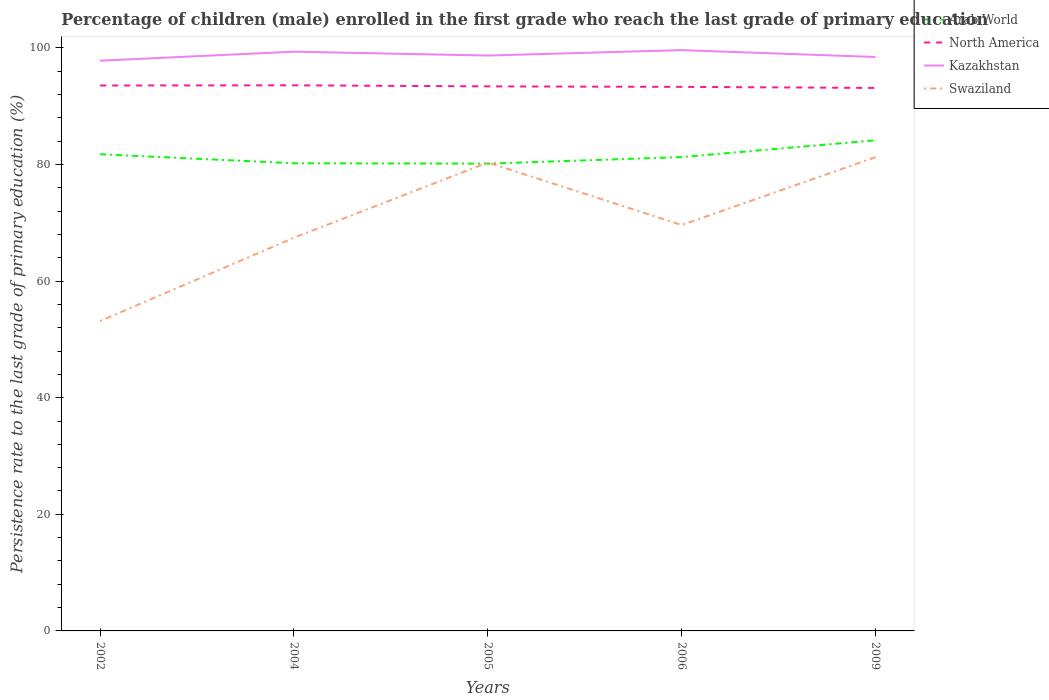Across all years, what is the maximum persistence rate of children in Swaziland?
Offer a terse response. 53.15. In which year was the persistence rate of children in Kazakhstan maximum?
Your answer should be compact. 2002. What is the total persistence rate of children in Swaziland in the graph?
Your response must be concise. -27.18. What is the difference between the highest and the second highest persistence rate of children in Arab World?
Give a very brief answer. 4.01. What is the difference between the highest and the lowest persistence rate of children in Swaziland?
Make the answer very short. 2. How many years are there in the graph?
Provide a succinct answer. 5. Does the graph contain grids?
Offer a very short reply. No. How are the legend labels stacked?
Offer a terse response. Vertical. What is the title of the graph?
Keep it short and to the point. Percentage of children (male) enrolled in the first grade who reach the last grade of primary education. Does "Malaysia" appear as one of the legend labels in the graph?
Give a very brief answer. No. What is the label or title of the X-axis?
Provide a succinct answer. Years. What is the label or title of the Y-axis?
Make the answer very short. Persistence rate to the last grade of primary education (%). What is the Persistence rate to the last grade of primary education (%) in Arab World in 2002?
Provide a succinct answer. 81.75. What is the Persistence rate to the last grade of primary education (%) in North America in 2002?
Ensure brevity in your answer.  93.54. What is the Persistence rate to the last grade of primary education (%) of Kazakhstan in 2002?
Offer a terse response. 97.79. What is the Persistence rate to the last grade of primary education (%) in Swaziland in 2002?
Ensure brevity in your answer.  53.15. What is the Persistence rate to the last grade of primary education (%) in Arab World in 2004?
Keep it short and to the point. 80.2. What is the Persistence rate to the last grade of primary education (%) in North America in 2004?
Ensure brevity in your answer.  93.57. What is the Persistence rate to the last grade of primary education (%) of Kazakhstan in 2004?
Your answer should be compact. 99.34. What is the Persistence rate to the last grade of primary education (%) in Swaziland in 2004?
Offer a terse response. 67.44. What is the Persistence rate to the last grade of primary education (%) in Arab World in 2005?
Provide a succinct answer. 80.13. What is the Persistence rate to the last grade of primary education (%) of North America in 2005?
Provide a succinct answer. 93.38. What is the Persistence rate to the last grade of primary education (%) in Kazakhstan in 2005?
Provide a short and direct response. 98.67. What is the Persistence rate to the last grade of primary education (%) in Swaziland in 2005?
Make the answer very short. 80.33. What is the Persistence rate to the last grade of primary education (%) in Arab World in 2006?
Ensure brevity in your answer.  81.26. What is the Persistence rate to the last grade of primary education (%) in North America in 2006?
Your answer should be very brief. 93.3. What is the Persistence rate to the last grade of primary education (%) in Kazakhstan in 2006?
Ensure brevity in your answer.  99.6. What is the Persistence rate to the last grade of primary education (%) in Swaziland in 2006?
Provide a short and direct response. 69.61. What is the Persistence rate to the last grade of primary education (%) in Arab World in 2009?
Your response must be concise. 84.14. What is the Persistence rate to the last grade of primary education (%) in North America in 2009?
Your response must be concise. 93.12. What is the Persistence rate to the last grade of primary education (%) of Kazakhstan in 2009?
Offer a very short reply. 98.42. What is the Persistence rate to the last grade of primary education (%) in Swaziland in 2009?
Make the answer very short. 81.24. Across all years, what is the maximum Persistence rate to the last grade of primary education (%) of Arab World?
Offer a very short reply. 84.14. Across all years, what is the maximum Persistence rate to the last grade of primary education (%) in North America?
Provide a succinct answer. 93.57. Across all years, what is the maximum Persistence rate to the last grade of primary education (%) of Kazakhstan?
Your response must be concise. 99.6. Across all years, what is the maximum Persistence rate to the last grade of primary education (%) in Swaziland?
Make the answer very short. 81.24. Across all years, what is the minimum Persistence rate to the last grade of primary education (%) of Arab World?
Give a very brief answer. 80.13. Across all years, what is the minimum Persistence rate to the last grade of primary education (%) of North America?
Make the answer very short. 93.12. Across all years, what is the minimum Persistence rate to the last grade of primary education (%) in Kazakhstan?
Offer a very short reply. 97.79. Across all years, what is the minimum Persistence rate to the last grade of primary education (%) of Swaziland?
Provide a succinct answer. 53.15. What is the total Persistence rate to the last grade of primary education (%) of Arab World in the graph?
Offer a very short reply. 407.49. What is the total Persistence rate to the last grade of primary education (%) in North America in the graph?
Offer a very short reply. 466.91. What is the total Persistence rate to the last grade of primary education (%) of Kazakhstan in the graph?
Provide a short and direct response. 493.83. What is the total Persistence rate to the last grade of primary education (%) of Swaziland in the graph?
Provide a short and direct response. 351.76. What is the difference between the Persistence rate to the last grade of primary education (%) in Arab World in 2002 and that in 2004?
Give a very brief answer. 1.55. What is the difference between the Persistence rate to the last grade of primary education (%) in North America in 2002 and that in 2004?
Provide a succinct answer. -0.03. What is the difference between the Persistence rate to the last grade of primary education (%) of Kazakhstan in 2002 and that in 2004?
Provide a succinct answer. -1.55. What is the difference between the Persistence rate to the last grade of primary education (%) of Swaziland in 2002 and that in 2004?
Provide a succinct answer. -14.29. What is the difference between the Persistence rate to the last grade of primary education (%) in Arab World in 2002 and that in 2005?
Give a very brief answer. 1.61. What is the difference between the Persistence rate to the last grade of primary education (%) in North America in 2002 and that in 2005?
Your answer should be very brief. 0.15. What is the difference between the Persistence rate to the last grade of primary education (%) in Kazakhstan in 2002 and that in 2005?
Give a very brief answer. -0.88. What is the difference between the Persistence rate to the last grade of primary education (%) in Swaziland in 2002 and that in 2005?
Provide a short and direct response. -27.18. What is the difference between the Persistence rate to the last grade of primary education (%) of Arab World in 2002 and that in 2006?
Provide a short and direct response. 0.48. What is the difference between the Persistence rate to the last grade of primary education (%) in North America in 2002 and that in 2006?
Offer a very short reply. 0.24. What is the difference between the Persistence rate to the last grade of primary education (%) of Kazakhstan in 2002 and that in 2006?
Ensure brevity in your answer.  -1.81. What is the difference between the Persistence rate to the last grade of primary education (%) in Swaziland in 2002 and that in 2006?
Keep it short and to the point. -16.46. What is the difference between the Persistence rate to the last grade of primary education (%) in Arab World in 2002 and that in 2009?
Your answer should be very brief. -2.4. What is the difference between the Persistence rate to the last grade of primary education (%) in North America in 2002 and that in 2009?
Offer a terse response. 0.41. What is the difference between the Persistence rate to the last grade of primary education (%) in Kazakhstan in 2002 and that in 2009?
Keep it short and to the point. -0.64. What is the difference between the Persistence rate to the last grade of primary education (%) in Swaziland in 2002 and that in 2009?
Give a very brief answer. -28.09. What is the difference between the Persistence rate to the last grade of primary education (%) of Arab World in 2004 and that in 2005?
Offer a very short reply. 0.07. What is the difference between the Persistence rate to the last grade of primary education (%) in North America in 2004 and that in 2005?
Your response must be concise. 0.18. What is the difference between the Persistence rate to the last grade of primary education (%) of Kazakhstan in 2004 and that in 2005?
Offer a very short reply. 0.66. What is the difference between the Persistence rate to the last grade of primary education (%) in Swaziland in 2004 and that in 2005?
Ensure brevity in your answer.  -12.9. What is the difference between the Persistence rate to the last grade of primary education (%) of Arab World in 2004 and that in 2006?
Keep it short and to the point. -1.06. What is the difference between the Persistence rate to the last grade of primary education (%) of North America in 2004 and that in 2006?
Your answer should be very brief. 0.27. What is the difference between the Persistence rate to the last grade of primary education (%) in Kazakhstan in 2004 and that in 2006?
Make the answer very short. -0.27. What is the difference between the Persistence rate to the last grade of primary education (%) in Swaziland in 2004 and that in 2006?
Your response must be concise. -2.17. What is the difference between the Persistence rate to the last grade of primary education (%) in Arab World in 2004 and that in 2009?
Your answer should be very brief. -3.94. What is the difference between the Persistence rate to the last grade of primary education (%) of North America in 2004 and that in 2009?
Keep it short and to the point. 0.45. What is the difference between the Persistence rate to the last grade of primary education (%) in Kazakhstan in 2004 and that in 2009?
Your answer should be very brief. 0.91. What is the difference between the Persistence rate to the last grade of primary education (%) of Swaziland in 2004 and that in 2009?
Provide a short and direct response. -13.8. What is the difference between the Persistence rate to the last grade of primary education (%) in Arab World in 2005 and that in 2006?
Your answer should be very brief. -1.13. What is the difference between the Persistence rate to the last grade of primary education (%) of North America in 2005 and that in 2006?
Provide a succinct answer. 0.08. What is the difference between the Persistence rate to the last grade of primary education (%) of Kazakhstan in 2005 and that in 2006?
Keep it short and to the point. -0.93. What is the difference between the Persistence rate to the last grade of primary education (%) of Swaziland in 2005 and that in 2006?
Your answer should be compact. 10.72. What is the difference between the Persistence rate to the last grade of primary education (%) in Arab World in 2005 and that in 2009?
Provide a succinct answer. -4.01. What is the difference between the Persistence rate to the last grade of primary education (%) in North America in 2005 and that in 2009?
Keep it short and to the point. 0.26. What is the difference between the Persistence rate to the last grade of primary education (%) in Kazakhstan in 2005 and that in 2009?
Provide a succinct answer. 0.25. What is the difference between the Persistence rate to the last grade of primary education (%) of Swaziland in 2005 and that in 2009?
Provide a succinct answer. -0.91. What is the difference between the Persistence rate to the last grade of primary education (%) of Arab World in 2006 and that in 2009?
Offer a very short reply. -2.88. What is the difference between the Persistence rate to the last grade of primary education (%) in North America in 2006 and that in 2009?
Offer a terse response. 0.18. What is the difference between the Persistence rate to the last grade of primary education (%) of Kazakhstan in 2006 and that in 2009?
Provide a succinct answer. 1.18. What is the difference between the Persistence rate to the last grade of primary education (%) in Swaziland in 2006 and that in 2009?
Give a very brief answer. -11.63. What is the difference between the Persistence rate to the last grade of primary education (%) in Arab World in 2002 and the Persistence rate to the last grade of primary education (%) in North America in 2004?
Keep it short and to the point. -11.82. What is the difference between the Persistence rate to the last grade of primary education (%) of Arab World in 2002 and the Persistence rate to the last grade of primary education (%) of Kazakhstan in 2004?
Offer a very short reply. -17.59. What is the difference between the Persistence rate to the last grade of primary education (%) of Arab World in 2002 and the Persistence rate to the last grade of primary education (%) of Swaziland in 2004?
Provide a short and direct response. 14.31. What is the difference between the Persistence rate to the last grade of primary education (%) in North America in 2002 and the Persistence rate to the last grade of primary education (%) in Kazakhstan in 2004?
Your answer should be compact. -5.8. What is the difference between the Persistence rate to the last grade of primary education (%) in North America in 2002 and the Persistence rate to the last grade of primary education (%) in Swaziland in 2004?
Provide a short and direct response. 26.1. What is the difference between the Persistence rate to the last grade of primary education (%) in Kazakhstan in 2002 and the Persistence rate to the last grade of primary education (%) in Swaziland in 2004?
Offer a very short reply. 30.35. What is the difference between the Persistence rate to the last grade of primary education (%) in Arab World in 2002 and the Persistence rate to the last grade of primary education (%) in North America in 2005?
Ensure brevity in your answer.  -11.64. What is the difference between the Persistence rate to the last grade of primary education (%) of Arab World in 2002 and the Persistence rate to the last grade of primary education (%) of Kazakhstan in 2005?
Provide a short and direct response. -16.93. What is the difference between the Persistence rate to the last grade of primary education (%) of Arab World in 2002 and the Persistence rate to the last grade of primary education (%) of Swaziland in 2005?
Your response must be concise. 1.42. What is the difference between the Persistence rate to the last grade of primary education (%) of North America in 2002 and the Persistence rate to the last grade of primary education (%) of Kazakhstan in 2005?
Offer a very short reply. -5.14. What is the difference between the Persistence rate to the last grade of primary education (%) of North America in 2002 and the Persistence rate to the last grade of primary education (%) of Swaziland in 2005?
Your response must be concise. 13.2. What is the difference between the Persistence rate to the last grade of primary education (%) in Kazakhstan in 2002 and the Persistence rate to the last grade of primary education (%) in Swaziland in 2005?
Provide a succinct answer. 17.46. What is the difference between the Persistence rate to the last grade of primary education (%) of Arab World in 2002 and the Persistence rate to the last grade of primary education (%) of North America in 2006?
Offer a very short reply. -11.55. What is the difference between the Persistence rate to the last grade of primary education (%) of Arab World in 2002 and the Persistence rate to the last grade of primary education (%) of Kazakhstan in 2006?
Ensure brevity in your answer.  -17.86. What is the difference between the Persistence rate to the last grade of primary education (%) of Arab World in 2002 and the Persistence rate to the last grade of primary education (%) of Swaziland in 2006?
Offer a very short reply. 12.14. What is the difference between the Persistence rate to the last grade of primary education (%) in North America in 2002 and the Persistence rate to the last grade of primary education (%) in Kazakhstan in 2006?
Make the answer very short. -6.07. What is the difference between the Persistence rate to the last grade of primary education (%) in North America in 2002 and the Persistence rate to the last grade of primary education (%) in Swaziland in 2006?
Your answer should be very brief. 23.93. What is the difference between the Persistence rate to the last grade of primary education (%) in Kazakhstan in 2002 and the Persistence rate to the last grade of primary education (%) in Swaziland in 2006?
Your answer should be compact. 28.18. What is the difference between the Persistence rate to the last grade of primary education (%) in Arab World in 2002 and the Persistence rate to the last grade of primary education (%) in North America in 2009?
Offer a terse response. -11.38. What is the difference between the Persistence rate to the last grade of primary education (%) in Arab World in 2002 and the Persistence rate to the last grade of primary education (%) in Kazakhstan in 2009?
Keep it short and to the point. -16.68. What is the difference between the Persistence rate to the last grade of primary education (%) of Arab World in 2002 and the Persistence rate to the last grade of primary education (%) of Swaziland in 2009?
Make the answer very short. 0.51. What is the difference between the Persistence rate to the last grade of primary education (%) in North America in 2002 and the Persistence rate to the last grade of primary education (%) in Kazakhstan in 2009?
Offer a terse response. -4.89. What is the difference between the Persistence rate to the last grade of primary education (%) in North America in 2002 and the Persistence rate to the last grade of primary education (%) in Swaziland in 2009?
Ensure brevity in your answer.  12.3. What is the difference between the Persistence rate to the last grade of primary education (%) of Kazakhstan in 2002 and the Persistence rate to the last grade of primary education (%) of Swaziland in 2009?
Offer a very short reply. 16.55. What is the difference between the Persistence rate to the last grade of primary education (%) of Arab World in 2004 and the Persistence rate to the last grade of primary education (%) of North America in 2005?
Make the answer very short. -13.18. What is the difference between the Persistence rate to the last grade of primary education (%) in Arab World in 2004 and the Persistence rate to the last grade of primary education (%) in Kazakhstan in 2005?
Give a very brief answer. -18.47. What is the difference between the Persistence rate to the last grade of primary education (%) in Arab World in 2004 and the Persistence rate to the last grade of primary education (%) in Swaziland in 2005?
Provide a short and direct response. -0.13. What is the difference between the Persistence rate to the last grade of primary education (%) of North America in 2004 and the Persistence rate to the last grade of primary education (%) of Kazakhstan in 2005?
Your response must be concise. -5.11. What is the difference between the Persistence rate to the last grade of primary education (%) in North America in 2004 and the Persistence rate to the last grade of primary education (%) in Swaziland in 2005?
Provide a succinct answer. 13.24. What is the difference between the Persistence rate to the last grade of primary education (%) of Kazakhstan in 2004 and the Persistence rate to the last grade of primary education (%) of Swaziland in 2005?
Keep it short and to the point. 19.01. What is the difference between the Persistence rate to the last grade of primary education (%) of Arab World in 2004 and the Persistence rate to the last grade of primary education (%) of North America in 2006?
Your response must be concise. -13.1. What is the difference between the Persistence rate to the last grade of primary education (%) in Arab World in 2004 and the Persistence rate to the last grade of primary education (%) in Kazakhstan in 2006?
Give a very brief answer. -19.4. What is the difference between the Persistence rate to the last grade of primary education (%) of Arab World in 2004 and the Persistence rate to the last grade of primary education (%) of Swaziland in 2006?
Ensure brevity in your answer.  10.59. What is the difference between the Persistence rate to the last grade of primary education (%) of North America in 2004 and the Persistence rate to the last grade of primary education (%) of Kazakhstan in 2006?
Ensure brevity in your answer.  -6.04. What is the difference between the Persistence rate to the last grade of primary education (%) in North America in 2004 and the Persistence rate to the last grade of primary education (%) in Swaziland in 2006?
Make the answer very short. 23.96. What is the difference between the Persistence rate to the last grade of primary education (%) in Kazakhstan in 2004 and the Persistence rate to the last grade of primary education (%) in Swaziland in 2006?
Your answer should be compact. 29.73. What is the difference between the Persistence rate to the last grade of primary education (%) of Arab World in 2004 and the Persistence rate to the last grade of primary education (%) of North America in 2009?
Offer a terse response. -12.92. What is the difference between the Persistence rate to the last grade of primary education (%) in Arab World in 2004 and the Persistence rate to the last grade of primary education (%) in Kazakhstan in 2009?
Offer a very short reply. -18.22. What is the difference between the Persistence rate to the last grade of primary education (%) in Arab World in 2004 and the Persistence rate to the last grade of primary education (%) in Swaziland in 2009?
Your answer should be compact. -1.04. What is the difference between the Persistence rate to the last grade of primary education (%) of North America in 2004 and the Persistence rate to the last grade of primary education (%) of Kazakhstan in 2009?
Your answer should be very brief. -4.86. What is the difference between the Persistence rate to the last grade of primary education (%) in North America in 2004 and the Persistence rate to the last grade of primary education (%) in Swaziland in 2009?
Give a very brief answer. 12.33. What is the difference between the Persistence rate to the last grade of primary education (%) of Kazakhstan in 2004 and the Persistence rate to the last grade of primary education (%) of Swaziland in 2009?
Give a very brief answer. 18.1. What is the difference between the Persistence rate to the last grade of primary education (%) of Arab World in 2005 and the Persistence rate to the last grade of primary education (%) of North America in 2006?
Your answer should be very brief. -13.17. What is the difference between the Persistence rate to the last grade of primary education (%) of Arab World in 2005 and the Persistence rate to the last grade of primary education (%) of Kazakhstan in 2006?
Ensure brevity in your answer.  -19.47. What is the difference between the Persistence rate to the last grade of primary education (%) in Arab World in 2005 and the Persistence rate to the last grade of primary education (%) in Swaziland in 2006?
Your response must be concise. 10.52. What is the difference between the Persistence rate to the last grade of primary education (%) of North America in 2005 and the Persistence rate to the last grade of primary education (%) of Kazakhstan in 2006?
Keep it short and to the point. -6.22. What is the difference between the Persistence rate to the last grade of primary education (%) in North America in 2005 and the Persistence rate to the last grade of primary education (%) in Swaziland in 2006?
Give a very brief answer. 23.77. What is the difference between the Persistence rate to the last grade of primary education (%) in Kazakhstan in 2005 and the Persistence rate to the last grade of primary education (%) in Swaziland in 2006?
Your answer should be compact. 29.06. What is the difference between the Persistence rate to the last grade of primary education (%) in Arab World in 2005 and the Persistence rate to the last grade of primary education (%) in North America in 2009?
Offer a terse response. -12.99. What is the difference between the Persistence rate to the last grade of primary education (%) of Arab World in 2005 and the Persistence rate to the last grade of primary education (%) of Kazakhstan in 2009?
Your answer should be compact. -18.29. What is the difference between the Persistence rate to the last grade of primary education (%) of Arab World in 2005 and the Persistence rate to the last grade of primary education (%) of Swaziland in 2009?
Keep it short and to the point. -1.1. What is the difference between the Persistence rate to the last grade of primary education (%) of North America in 2005 and the Persistence rate to the last grade of primary education (%) of Kazakhstan in 2009?
Provide a succinct answer. -5.04. What is the difference between the Persistence rate to the last grade of primary education (%) of North America in 2005 and the Persistence rate to the last grade of primary education (%) of Swaziland in 2009?
Offer a terse response. 12.15. What is the difference between the Persistence rate to the last grade of primary education (%) of Kazakhstan in 2005 and the Persistence rate to the last grade of primary education (%) of Swaziland in 2009?
Your answer should be very brief. 17.43. What is the difference between the Persistence rate to the last grade of primary education (%) in Arab World in 2006 and the Persistence rate to the last grade of primary education (%) in North America in 2009?
Give a very brief answer. -11.86. What is the difference between the Persistence rate to the last grade of primary education (%) of Arab World in 2006 and the Persistence rate to the last grade of primary education (%) of Kazakhstan in 2009?
Provide a short and direct response. -17.16. What is the difference between the Persistence rate to the last grade of primary education (%) in Arab World in 2006 and the Persistence rate to the last grade of primary education (%) in Swaziland in 2009?
Offer a very short reply. 0.02. What is the difference between the Persistence rate to the last grade of primary education (%) of North America in 2006 and the Persistence rate to the last grade of primary education (%) of Kazakhstan in 2009?
Your answer should be very brief. -5.12. What is the difference between the Persistence rate to the last grade of primary education (%) of North America in 2006 and the Persistence rate to the last grade of primary education (%) of Swaziland in 2009?
Provide a short and direct response. 12.06. What is the difference between the Persistence rate to the last grade of primary education (%) in Kazakhstan in 2006 and the Persistence rate to the last grade of primary education (%) in Swaziland in 2009?
Keep it short and to the point. 18.36. What is the average Persistence rate to the last grade of primary education (%) of Arab World per year?
Your response must be concise. 81.5. What is the average Persistence rate to the last grade of primary education (%) of North America per year?
Offer a very short reply. 93.38. What is the average Persistence rate to the last grade of primary education (%) in Kazakhstan per year?
Provide a short and direct response. 98.77. What is the average Persistence rate to the last grade of primary education (%) of Swaziland per year?
Your answer should be very brief. 70.35. In the year 2002, what is the difference between the Persistence rate to the last grade of primary education (%) in Arab World and Persistence rate to the last grade of primary education (%) in North America?
Offer a very short reply. -11.79. In the year 2002, what is the difference between the Persistence rate to the last grade of primary education (%) of Arab World and Persistence rate to the last grade of primary education (%) of Kazakhstan?
Provide a succinct answer. -16.04. In the year 2002, what is the difference between the Persistence rate to the last grade of primary education (%) of Arab World and Persistence rate to the last grade of primary education (%) of Swaziland?
Your response must be concise. 28.6. In the year 2002, what is the difference between the Persistence rate to the last grade of primary education (%) in North America and Persistence rate to the last grade of primary education (%) in Kazakhstan?
Provide a short and direct response. -4.25. In the year 2002, what is the difference between the Persistence rate to the last grade of primary education (%) of North America and Persistence rate to the last grade of primary education (%) of Swaziland?
Provide a succinct answer. 40.39. In the year 2002, what is the difference between the Persistence rate to the last grade of primary education (%) of Kazakhstan and Persistence rate to the last grade of primary education (%) of Swaziland?
Your answer should be compact. 44.64. In the year 2004, what is the difference between the Persistence rate to the last grade of primary education (%) of Arab World and Persistence rate to the last grade of primary education (%) of North America?
Your response must be concise. -13.37. In the year 2004, what is the difference between the Persistence rate to the last grade of primary education (%) in Arab World and Persistence rate to the last grade of primary education (%) in Kazakhstan?
Keep it short and to the point. -19.14. In the year 2004, what is the difference between the Persistence rate to the last grade of primary education (%) of Arab World and Persistence rate to the last grade of primary education (%) of Swaziland?
Your response must be concise. 12.76. In the year 2004, what is the difference between the Persistence rate to the last grade of primary education (%) in North America and Persistence rate to the last grade of primary education (%) in Kazakhstan?
Give a very brief answer. -5.77. In the year 2004, what is the difference between the Persistence rate to the last grade of primary education (%) in North America and Persistence rate to the last grade of primary education (%) in Swaziland?
Make the answer very short. 26.13. In the year 2004, what is the difference between the Persistence rate to the last grade of primary education (%) in Kazakhstan and Persistence rate to the last grade of primary education (%) in Swaziland?
Make the answer very short. 31.9. In the year 2005, what is the difference between the Persistence rate to the last grade of primary education (%) in Arab World and Persistence rate to the last grade of primary education (%) in North America?
Give a very brief answer. -13.25. In the year 2005, what is the difference between the Persistence rate to the last grade of primary education (%) of Arab World and Persistence rate to the last grade of primary education (%) of Kazakhstan?
Keep it short and to the point. -18.54. In the year 2005, what is the difference between the Persistence rate to the last grade of primary education (%) of Arab World and Persistence rate to the last grade of primary education (%) of Swaziland?
Ensure brevity in your answer.  -0.2. In the year 2005, what is the difference between the Persistence rate to the last grade of primary education (%) in North America and Persistence rate to the last grade of primary education (%) in Kazakhstan?
Keep it short and to the point. -5.29. In the year 2005, what is the difference between the Persistence rate to the last grade of primary education (%) of North America and Persistence rate to the last grade of primary education (%) of Swaziland?
Make the answer very short. 13.05. In the year 2005, what is the difference between the Persistence rate to the last grade of primary education (%) in Kazakhstan and Persistence rate to the last grade of primary education (%) in Swaziland?
Provide a short and direct response. 18.34. In the year 2006, what is the difference between the Persistence rate to the last grade of primary education (%) in Arab World and Persistence rate to the last grade of primary education (%) in North America?
Give a very brief answer. -12.04. In the year 2006, what is the difference between the Persistence rate to the last grade of primary education (%) in Arab World and Persistence rate to the last grade of primary education (%) in Kazakhstan?
Your response must be concise. -18.34. In the year 2006, what is the difference between the Persistence rate to the last grade of primary education (%) of Arab World and Persistence rate to the last grade of primary education (%) of Swaziland?
Give a very brief answer. 11.65. In the year 2006, what is the difference between the Persistence rate to the last grade of primary education (%) of North America and Persistence rate to the last grade of primary education (%) of Kazakhstan?
Provide a succinct answer. -6.3. In the year 2006, what is the difference between the Persistence rate to the last grade of primary education (%) in North America and Persistence rate to the last grade of primary education (%) in Swaziland?
Your answer should be very brief. 23.69. In the year 2006, what is the difference between the Persistence rate to the last grade of primary education (%) of Kazakhstan and Persistence rate to the last grade of primary education (%) of Swaziland?
Ensure brevity in your answer.  29.99. In the year 2009, what is the difference between the Persistence rate to the last grade of primary education (%) of Arab World and Persistence rate to the last grade of primary education (%) of North America?
Your answer should be very brief. -8.98. In the year 2009, what is the difference between the Persistence rate to the last grade of primary education (%) in Arab World and Persistence rate to the last grade of primary education (%) in Kazakhstan?
Offer a terse response. -14.28. In the year 2009, what is the difference between the Persistence rate to the last grade of primary education (%) in Arab World and Persistence rate to the last grade of primary education (%) in Swaziland?
Make the answer very short. 2.9. In the year 2009, what is the difference between the Persistence rate to the last grade of primary education (%) of North America and Persistence rate to the last grade of primary education (%) of Kazakhstan?
Give a very brief answer. -5.3. In the year 2009, what is the difference between the Persistence rate to the last grade of primary education (%) in North America and Persistence rate to the last grade of primary education (%) in Swaziland?
Provide a succinct answer. 11.88. In the year 2009, what is the difference between the Persistence rate to the last grade of primary education (%) in Kazakhstan and Persistence rate to the last grade of primary education (%) in Swaziland?
Offer a very short reply. 17.19. What is the ratio of the Persistence rate to the last grade of primary education (%) of Arab World in 2002 to that in 2004?
Keep it short and to the point. 1.02. What is the ratio of the Persistence rate to the last grade of primary education (%) in Kazakhstan in 2002 to that in 2004?
Make the answer very short. 0.98. What is the ratio of the Persistence rate to the last grade of primary education (%) in Swaziland in 2002 to that in 2004?
Keep it short and to the point. 0.79. What is the ratio of the Persistence rate to the last grade of primary education (%) of Arab World in 2002 to that in 2005?
Your answer should be very brief. 1.02. What is the ratio of the Persistence rate to the last grade of primary education (%) in North America in 2002 to that in 2005?
Offer a terse response. 1. What is the ratio of the Persistence rate to the last grade of primary education (%) in Kazakhstan in 2002 to that in 2005?
Give a very brief answer. 0.99. What is the ratio of the Persistence rate to the last grade of primary education (%) of Swaziland in 2002 to that in 2005?
Make the answer very short. 0.66. What is the ratio of the Persistence rate to the last grade of primary education (%) in Arab World in 2002 to that in 2006?
Offer a very short reply. 1.01. What is the ratio of the Persistence rate to the last grade of primary education (%) in Kazakhstan in 2002 to that in 2006?
Your answer should be very brief. 0.98. What is the ratio of the Persistence rate to the last grade of primary education (%) of Swaziland in 2002 to that in 2006?
Give a very brief answer. 0.76. What is the ratio of the Persistence rate to the last grade of primary education (%) of Arab World in 2002 to that in 2009?
Your answer should be compact. 0.97. What is the ratio of the Persistence rate to the last grade of primary education (%) in North America in 2002 to that in 2009?
Keep it short and to the point. 1. What is the ratio of the Persistence rate to the last grade of primary education (%) of Swaziland in 2002 to that in 2009?
Your answer should be compact. 0.65. What is the ratio of the Persistence rate to the last grade of primary education (%) in Arab World in 2004 to that in 2005?
Offer a terse response. 1. What is the ratio of the Persistence rate to the last grade of primary education (%) of Swaziland in 2004 to that in 2005?
Your response must be concise. 0.84. What is the ratio of the Persistence rate to the last grade of primary education (%) in Arab World in 2004 to that in 2006?
Provide a succinct answer. 0.99. What is the ratio of the Persistence rate to the last grade of primary education (%) of North America in 2004 to that in 2006?
Keep it short and to the point. 1. What is the ratio of the Persistence rate to the last grade of primary education (%) in Swaziland in 2004 to that in 2006?
Your answer should be very brief. 0.97. What is the ratio of the Persistence rate to the last grade of primary education (%) in Arab World in 2004 to that in 2009?
Offer a terse response. 0.95. What is the ratio of the Persistence rate to the last grade of primary education (%) of Kazakhstan in 2004 to that in 2009?
Give a very brief answer. 1.01. What is the ratio of the Persistence rate to the last grade of primary education (%) in Swaziland in 2004 to that in 2009?
Your answer should be compact. 0.83. What is the ratio of the Persistence rate to the last grade of primary education (%) of Arab World in 2005 to that in 2006?
Offer a terse response. 0.99. What is the ratio of the Persistence rate to the last grade of primary education (%) in Swaziland in 2005 to that in 2006?
Ensure brevity in your answer.  1.15. What is the ratio of the Persistence rate to the last grade of primary education (%) of Arab World in 2005 to that in 2009?
Provide a succinct answer. 0.95. What is the ratio of the Persistence rate to the last grade of primary education (%) of Kazakhstan in 2005 to that in 2009?
Give a very brief answer. 1. What is the ratio of the Persistence rate to the last grade of primary education (%) of Swaziland in 2005 to that in 2009?
Make the answer very short. 0.99. What is the ratio of the Persistence rate to the last grade of primary education (%) in Arab World in 2006 to that in 2009?
Provide a short and direct response. 0.97. What is the ratio of the Persistence rate to the last grade of primary education (%) in Swaziland in 2006 to that in 2009?
Keep it short and to the point. 0.86. What is the difference between the highest and the second highest Persistence rate to the last grade of primary education (%) of Arab World?
Offer a terse response. 2.4. What is the difference between the highest and the second highest Persistence rate to the last grade of primary education (%) of North America?
Offer a very short reply. 0.03. What is the difference between the highest and the second highest Persistence rate to the last grade of primary education (%) of Kazakhstan?
Provide a succinct answer. 0.27. What is the difference between the highest and the second highest Persistence rate to the last grade of primary education (%) of Swaziland?
Give a very brief answer. 0.91. What is the difference between the highest and the lowest Persistence rate to the last grade of primary education (%) in Arab World?
Offer a terse response. 4.01. What is the difference between the highest and the lowest Persistence rate to the last grade of primary education (%) in North America?
Your answer should be very brief. 0.45. What is the difference between the highest and the lowest Persistence rate to the last grade of primary education (%) of Kazakhstan?
Offer a very short reply. 1.81. What is the difference between the highest and the lowest Persistence rate to the last grade of primary education (%) in Swaziland?
Give a very brief answer. 28.09. 